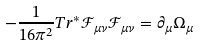<formula> <loc_0><loc_0><loc_500><loc_500>- { \frac { 1 } { 1 6 \pi ^ { 2 } } } T r ^ { * } { \mathcal { F } } _ { \mu \nu } { \mathcal { F } } _ { \mu \nu } = \partial _ { \mu } \Omega _ { \mu }</formula> 